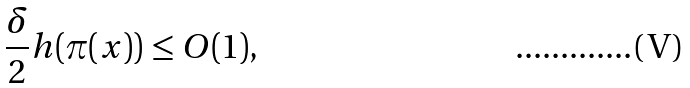<formula> <loc_0><loc_0><loc_500><loc_500>\frac { \delta } 2 h ( \pi ( x ) ) \leq O ( 1 ) ,</formula> 